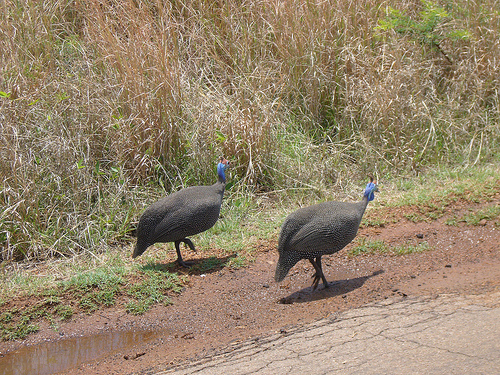<image>
Is there a water behind the peacock? Yes. From this viewpoint, the water is positioned behind the peacock, with the peacock partially or fully occluding the water. Where is the hen in relation to the shadow? Is it in front of the shadow? No. The hen is not in front of the shadow. The spatial positioning shows a different relationship between these objects. 